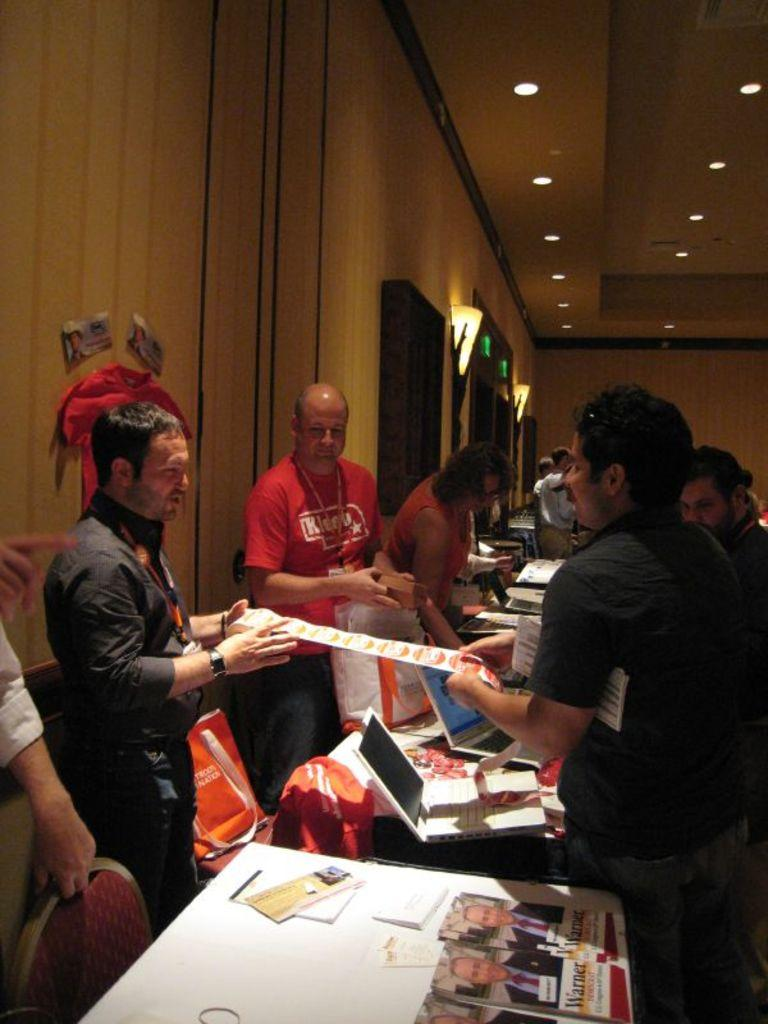Provide a one-sentence caption for the provided image. Several people at what looks like a trade show with copies of warner magazine on the table. 